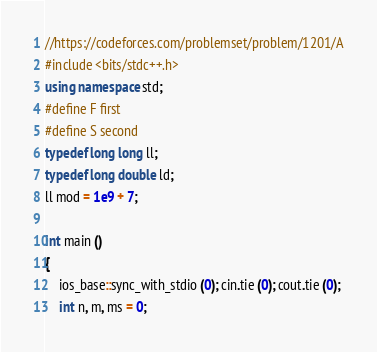<code> <loc_0><loc_0><loc_500><loc_500><_C++_>//https://codeforces.com/problemset/problem/1201/A
#include <bits/stdc++.h>
using namespace std;
#define F first 
#define S second
typedef long long ll;
typedef long double ld;
ll mod = 1e9 + 7;

int main ()
{
	ios_base::sync_with_stdio (0); cin.tie (0); cout.tie (0);
	int n, m, ms = 0;</code> 